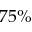<formula> <loc_0><loc_0><loc_500><loc_500>7 5 \%</formula> 